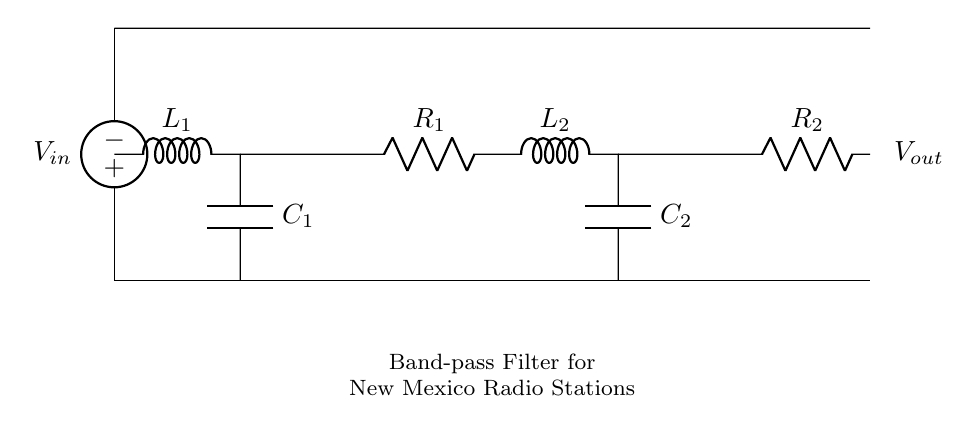What is the type of the input voltage source? The input voltage source is labeled as an "American voltage source," indicating it is alternating current (AC) used for radio signals.
Answer: American voltage source What components are used in this band-pass filter? The components present are two inductors (labeled L1 and L2), two capacitors (labeled C1 and C2), and two resistors (labeled R1 and R2).
Answer: Inductors, capacitors, resistors How many capacitors are present in the circuit? The diagram shows two capacitors, indicated by C1 and C2, positioned in the circuit.
Answer: Two What is the arrangement of the components? The arrangement shows a series combination of L1 and C1, followed by a combination of R1, L2, and C2, then R2 connected at the end.
Answer: Series and parallel What is the purpose of this circuit? The circuit functions as a band-pass filter designed to improve reception of local radio stations by allowing specific frequency ranges to pass while blocking others.
Answer: Band-pass filter What is the output connection labeled in the circuit? The output is labeled as "Vout," which indicates where the filtered signal is taken from after passing through the filter components.
Answer: Vout What role does each resistor play in the circuit? The resistors R1 and R2 help to control the current flow and influence the overall impedance within the band-pass filter, affecting the circuit's frequency response.
Answer: Current control 